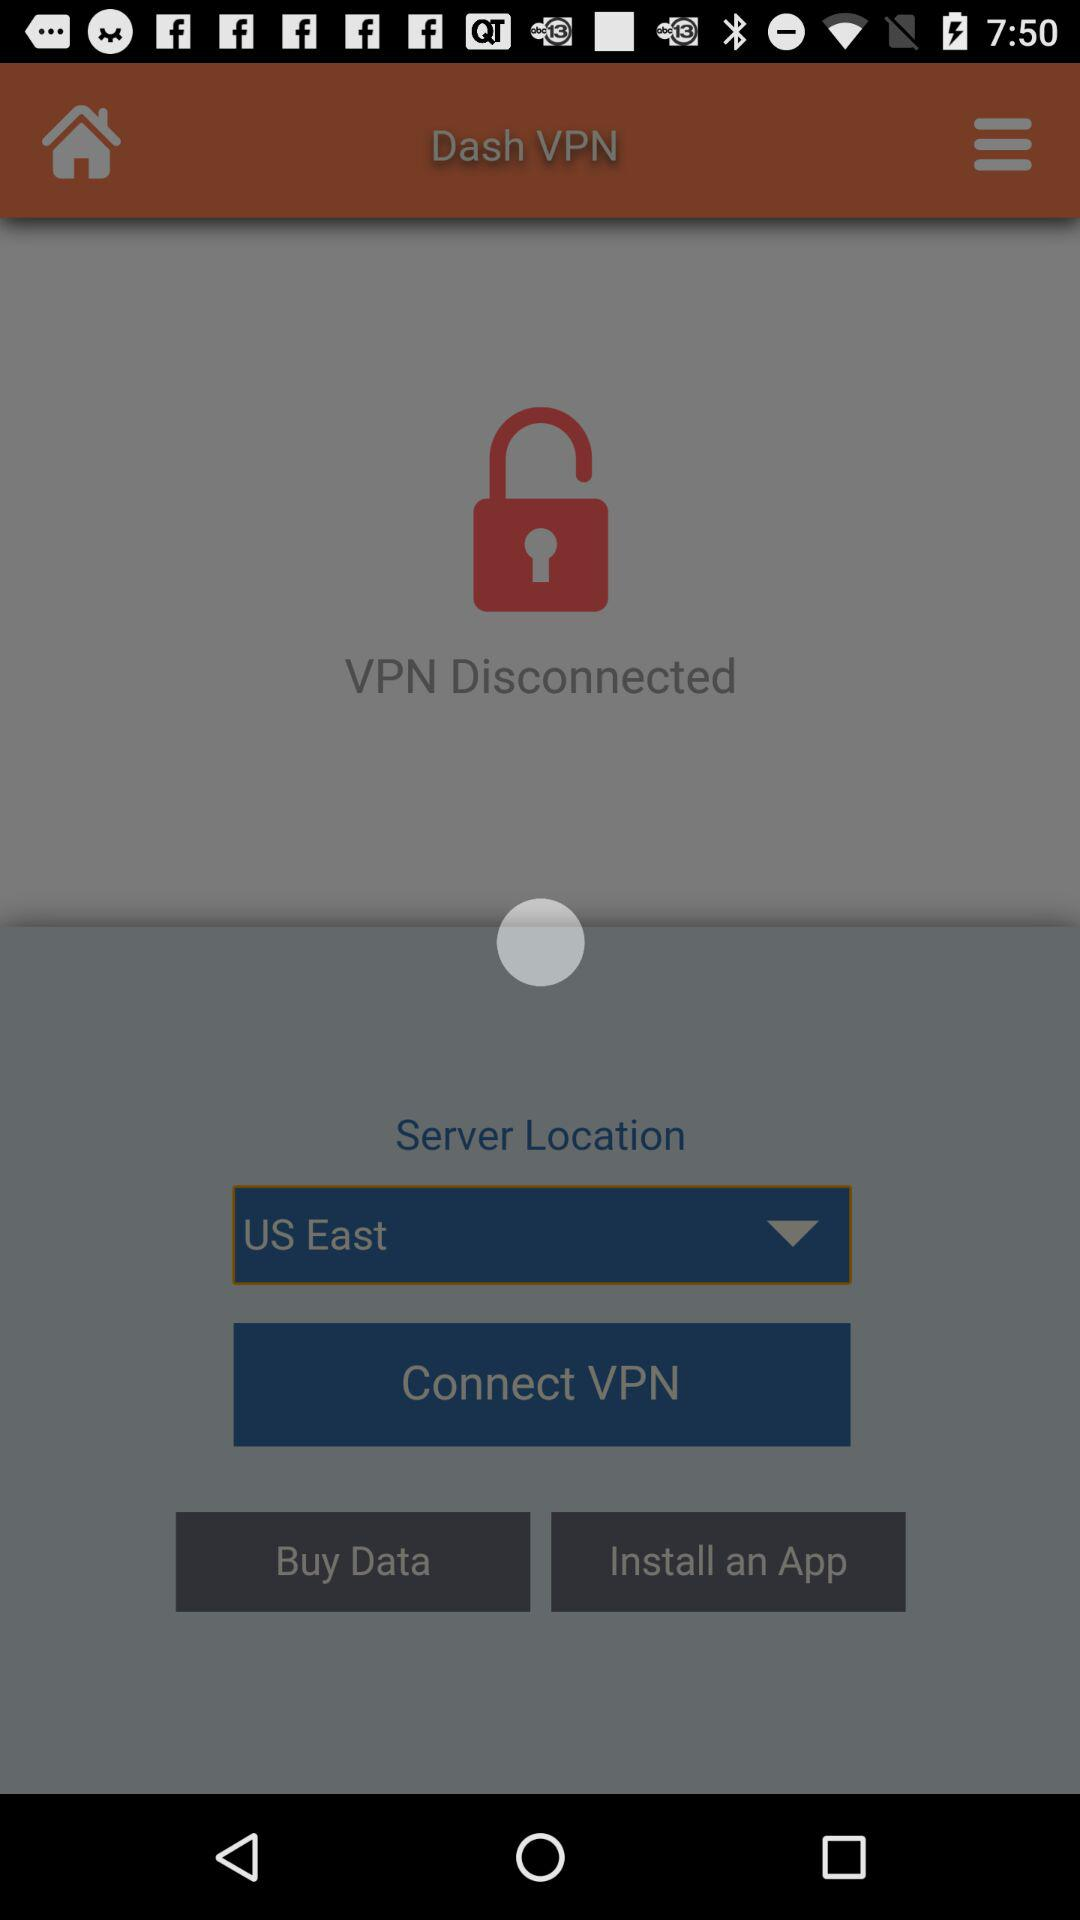Where is the server located? The server is located in the eastern US. 